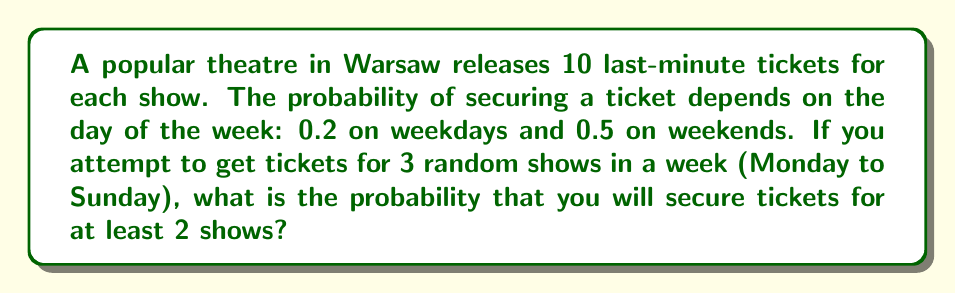Give your solution to this math problem. Let's approach this step-by-step:

1) First, we need to calculate the probability of getting a ticket on any given day:
   $P(\text{weekday}) = \frac{5}{7}$ and $P(\text{weekend}) = \frac{2}{7}$
   
   $P(\text{ticket}) = P(\text{weekday}) \cdot 0.2 + P(\text{weekend}) \cdot 0.5$
   $= \frac{5}{7} \cdot 0.2 + \frac{2}{7} \cdot 0.5 = 0.1429 + 0.1429 = 0.2858$

2) Now, we can treat this as a binomial probability problem. We want the probability of at least 2 successes in 3 trials.

3) The probability of exactly 2 successes:
   $P(X=2) = \binom{3}{2} \cdot 0.2858^2 \cdot (1-0.2858)^1$
   $= 3 \cdot 0.0817 \cdot 0.7142 = 0.1750$

4) The probability of exactly 3 successes:
   $P(X=3) = \binom{3}{3} \cdot 0.2858^3$
   $= 0.0233$

5) The probability of at least 2 successes is the sum of these probabilities:
   $P(X \geq 2) = P(X=2) + P(X=3) = 0.1750 + 0.0233 = 0.1983$
Answer: 0.1983 